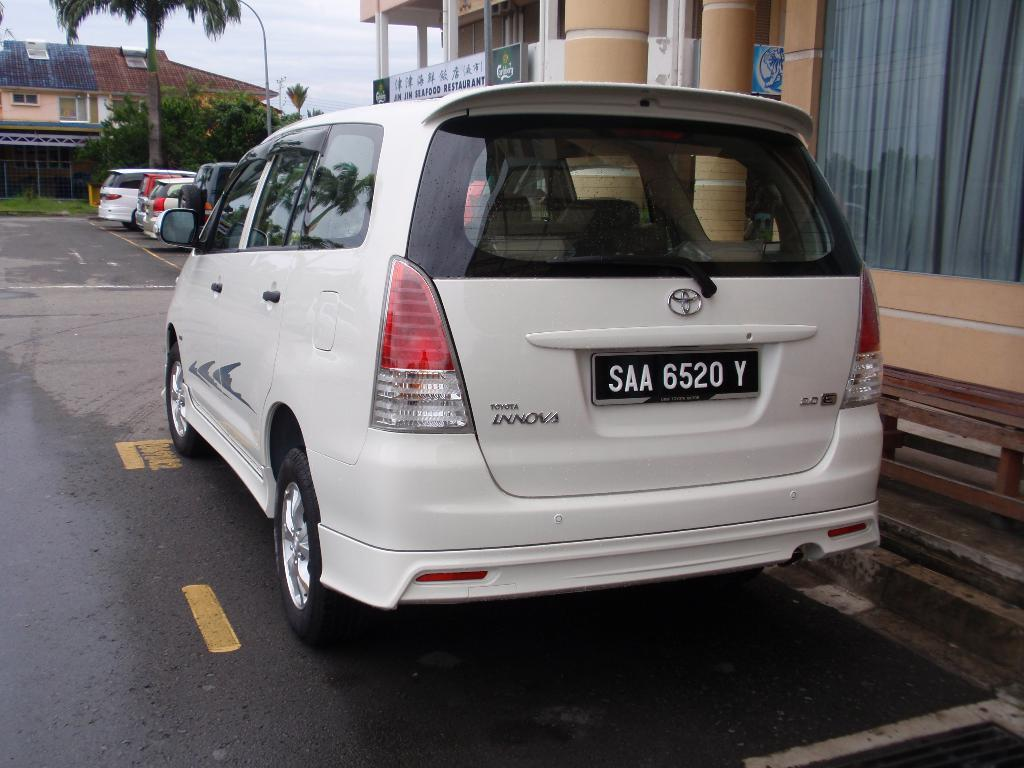<image>
Provide a brief description of the given image. A white car which has a numberplate on which the letters SAA are visible. 